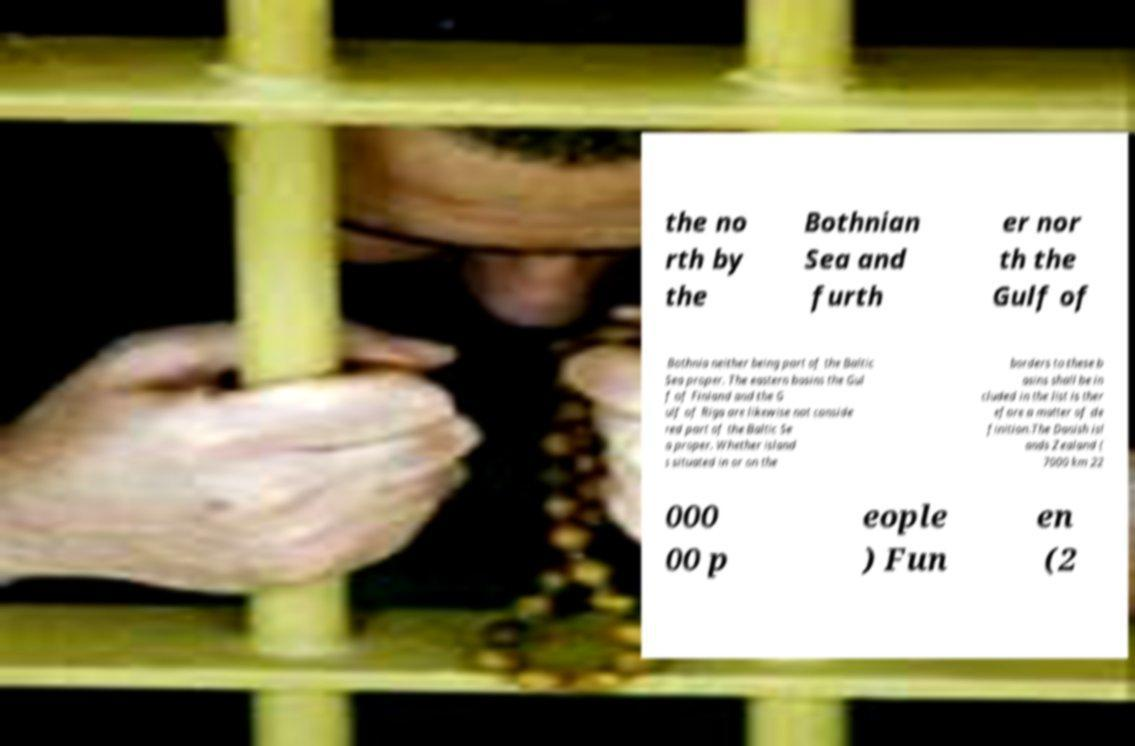Can you accurately transcribe the text from the provided image for me? the no rth by the Bothnian Sea and furth er nor th the Gulf of Bothnia neither being part of the Baltic Sea proper. The eastern basins the Gul f of Finland and the G ulf of Riga are likewise not conside red part of the Baltic Se a proper. Whether island s situated in or on the borders to these b asins shall be in cluded in the list is ther efore a matter of de finition.The Danish isl ands Zealand ( 7000 km 22 000 00 p eople ) Fun en (2 